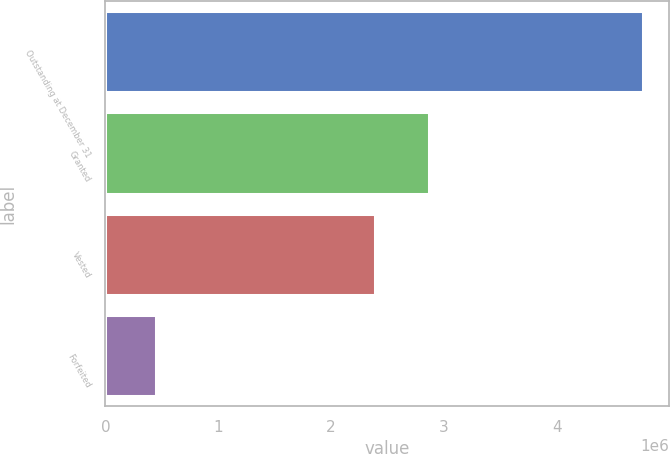Convert chart. <chart><loc_0><loc_0><loc_500><loc_500><bar_chart><fcel>Outstanding at December 31<fcel>Granted<fcel>Vested<fcel>Forfeited<nl><fcel>4.75838e+06<fcel>2.86271e+06<fcel>2.39284e+06<fcel>446985<nl></chart> 